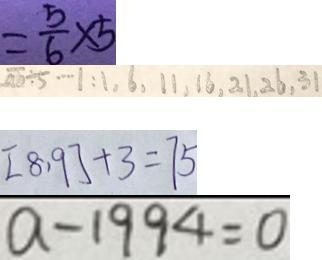Convert formula to latex. <formula><loc_0><loc_0><loc_500><loc_500>= \frac { 5 } { 6 } \times 5 
 \overline { a b } \div 5 \cdots 1 : 1 , 6 , 1 1 , 1 6 , 2 1 , 2 6 , 3 1 
 [ 8 , 9 ] + 3 = 7 5 
 a - 1 9 9 4 = 0</formula> 